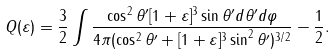Convert formula to latex. <formula><loc_0><loc_0><loc_500><loc_500>Q ( \varepsilon ) = \frac { 3 } { 2 } \int \frac { \cos ^ { 2 } \theta ^ { \prime } [ 1 + \varepsilon ] ^ { 3 } \sin \theta ^ { \prime } d \theta ^ { \prime } d \varphi } { 4 \pi ( \cos ^ { 2 } \theta ^ { \prime } + [ 1 + \varepsilon ] ^ { 3 } \sin ^ { 2 } \theta ^ { \prime } ) ^ { 3 / 2 } } - \frac { 1 } { 2 } .</formula> 